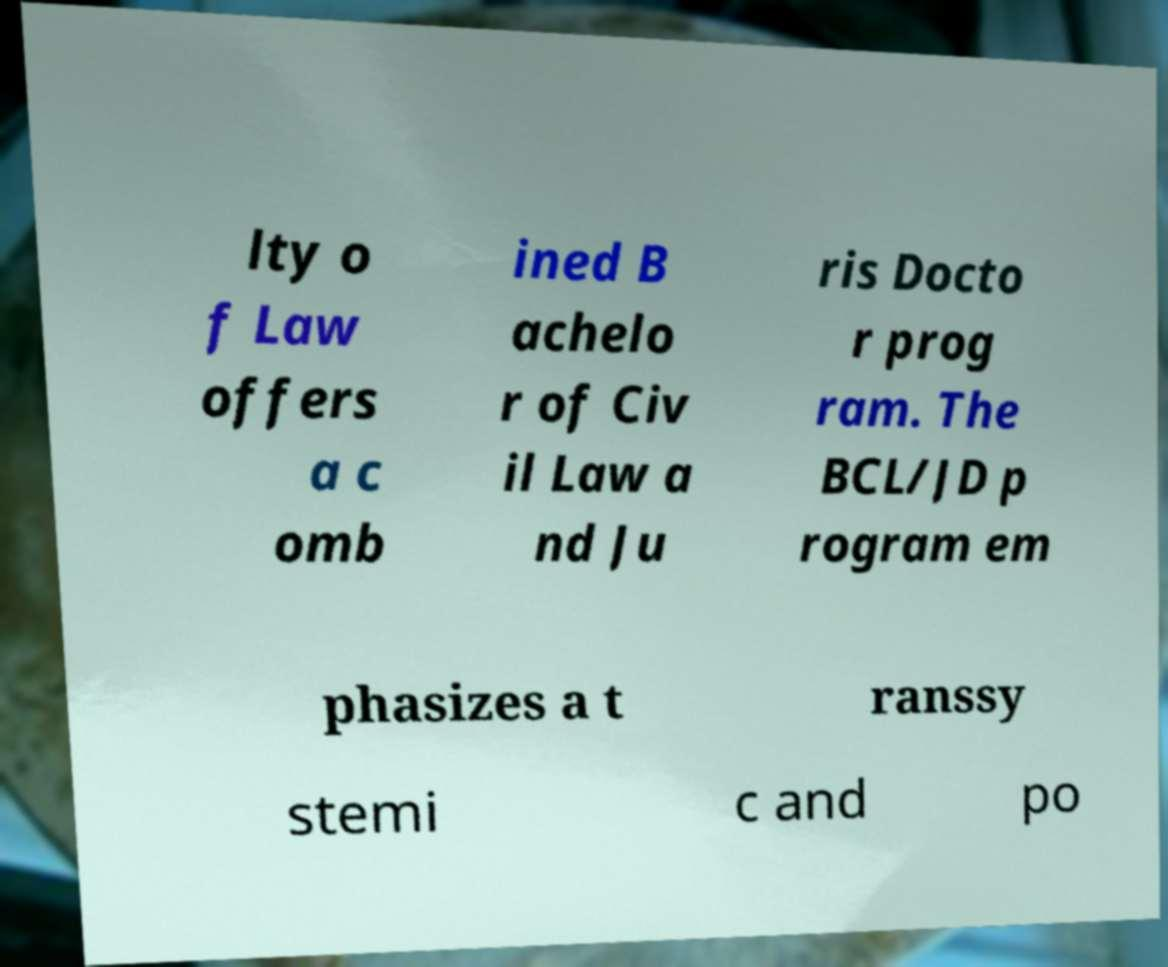I need the written content from this picture converted into text. Can you do that? lty o f Law offers a c omb ined B achelo r of Civ il Law a nd Ju ris Docto r prog ram. The BCL/JD p rogram em phasizes a t ranssy stemi c and po 